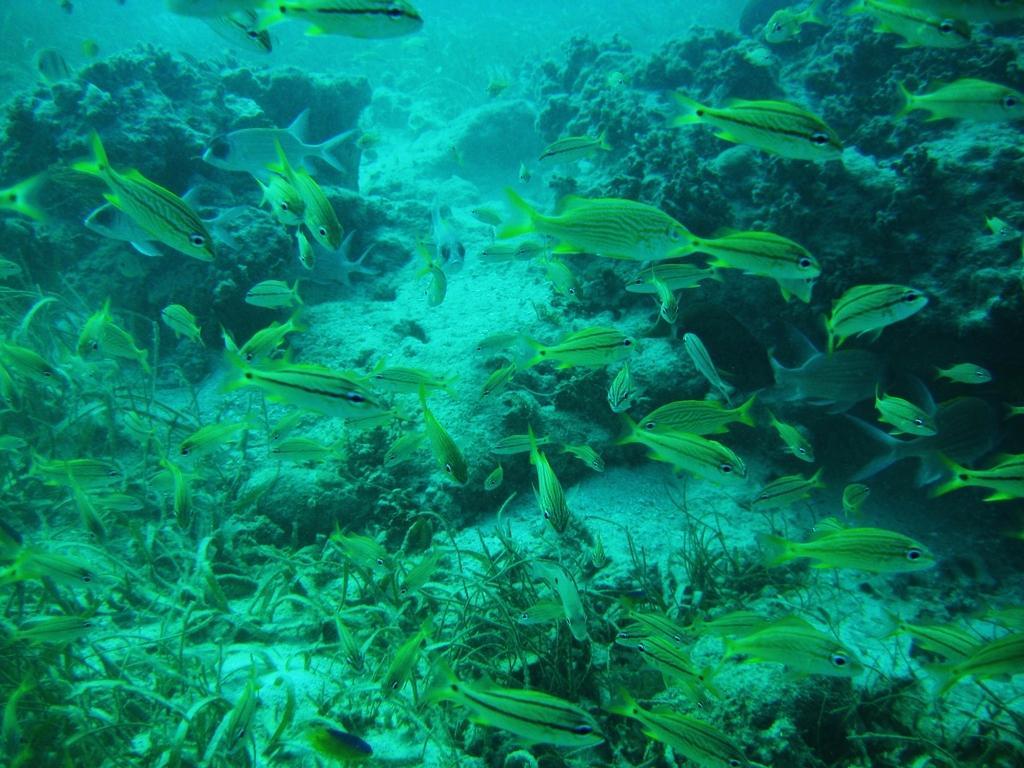How would you summarize this image in a sentence or two? In this picture we can see fishes, grass and corals in the water. 